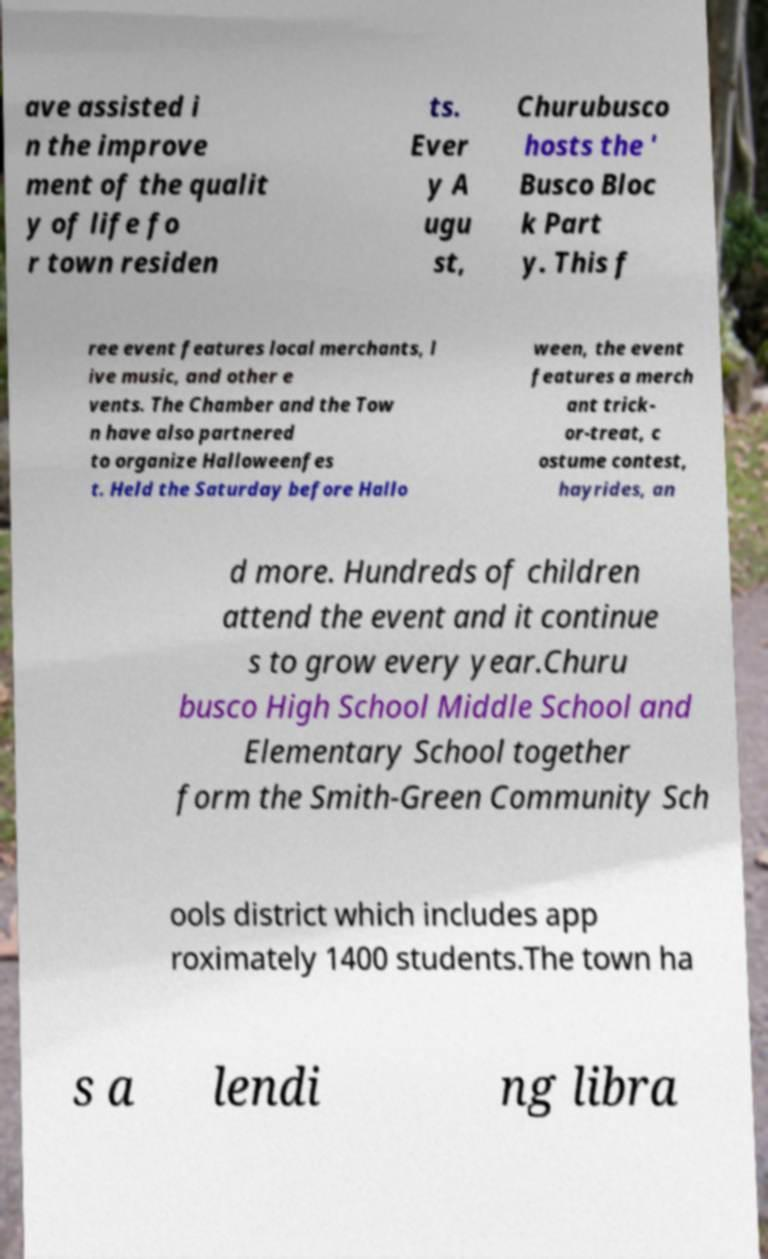For documentation purposes, I need the text within this image transcribed. Could you provide that? ave assisted i n the improve ment of the qualit y of life fo r town residen ts. Ever y A ugu st, Churubusco hosts the ' Busco Bloc k Part y. This f ree event features local merchants, l ive music, and other e vents. The Chamber and the Tow n have also partnered to organize Halloweenfes t. Held the Saturday before Hallo ween, the event features a merch ant trick- or-treat, c ostume contest, hayrides, an d more. Hundreds of children attend the event and it continue s to grow every year.Churu busco High School Middle School and Elementary School together form the Smith-Green Community Sch ools district which includes app roximately 1400 students.The town ha s a lendi ng libra 